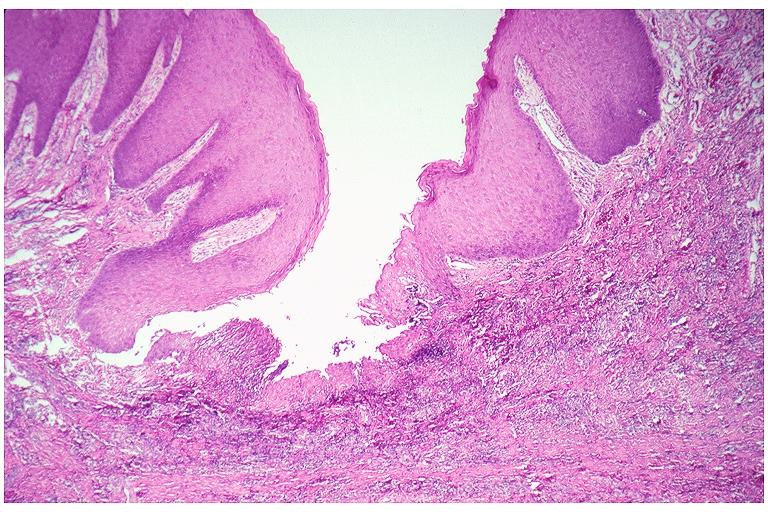where is this?
Answer the question using a single word or phrase. Oral 